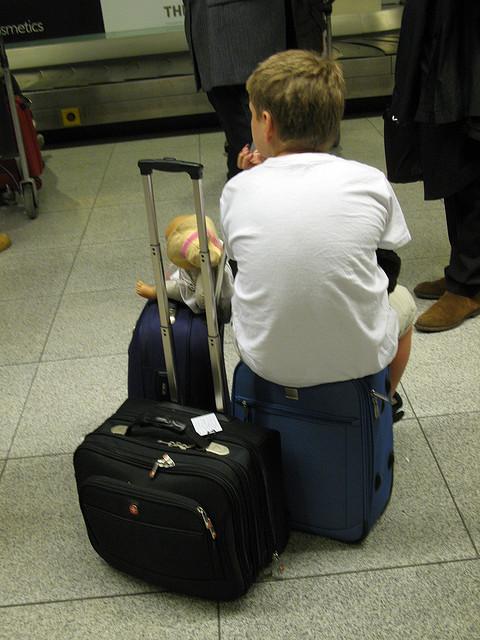What color is the suitcase that the man is sitting on?
Quick response, please. Blue. What is the boy sitting on?
Answer briefly. Suitcase. Is the extended handle higher than the boy's waist?
Short answer required. Yes. 